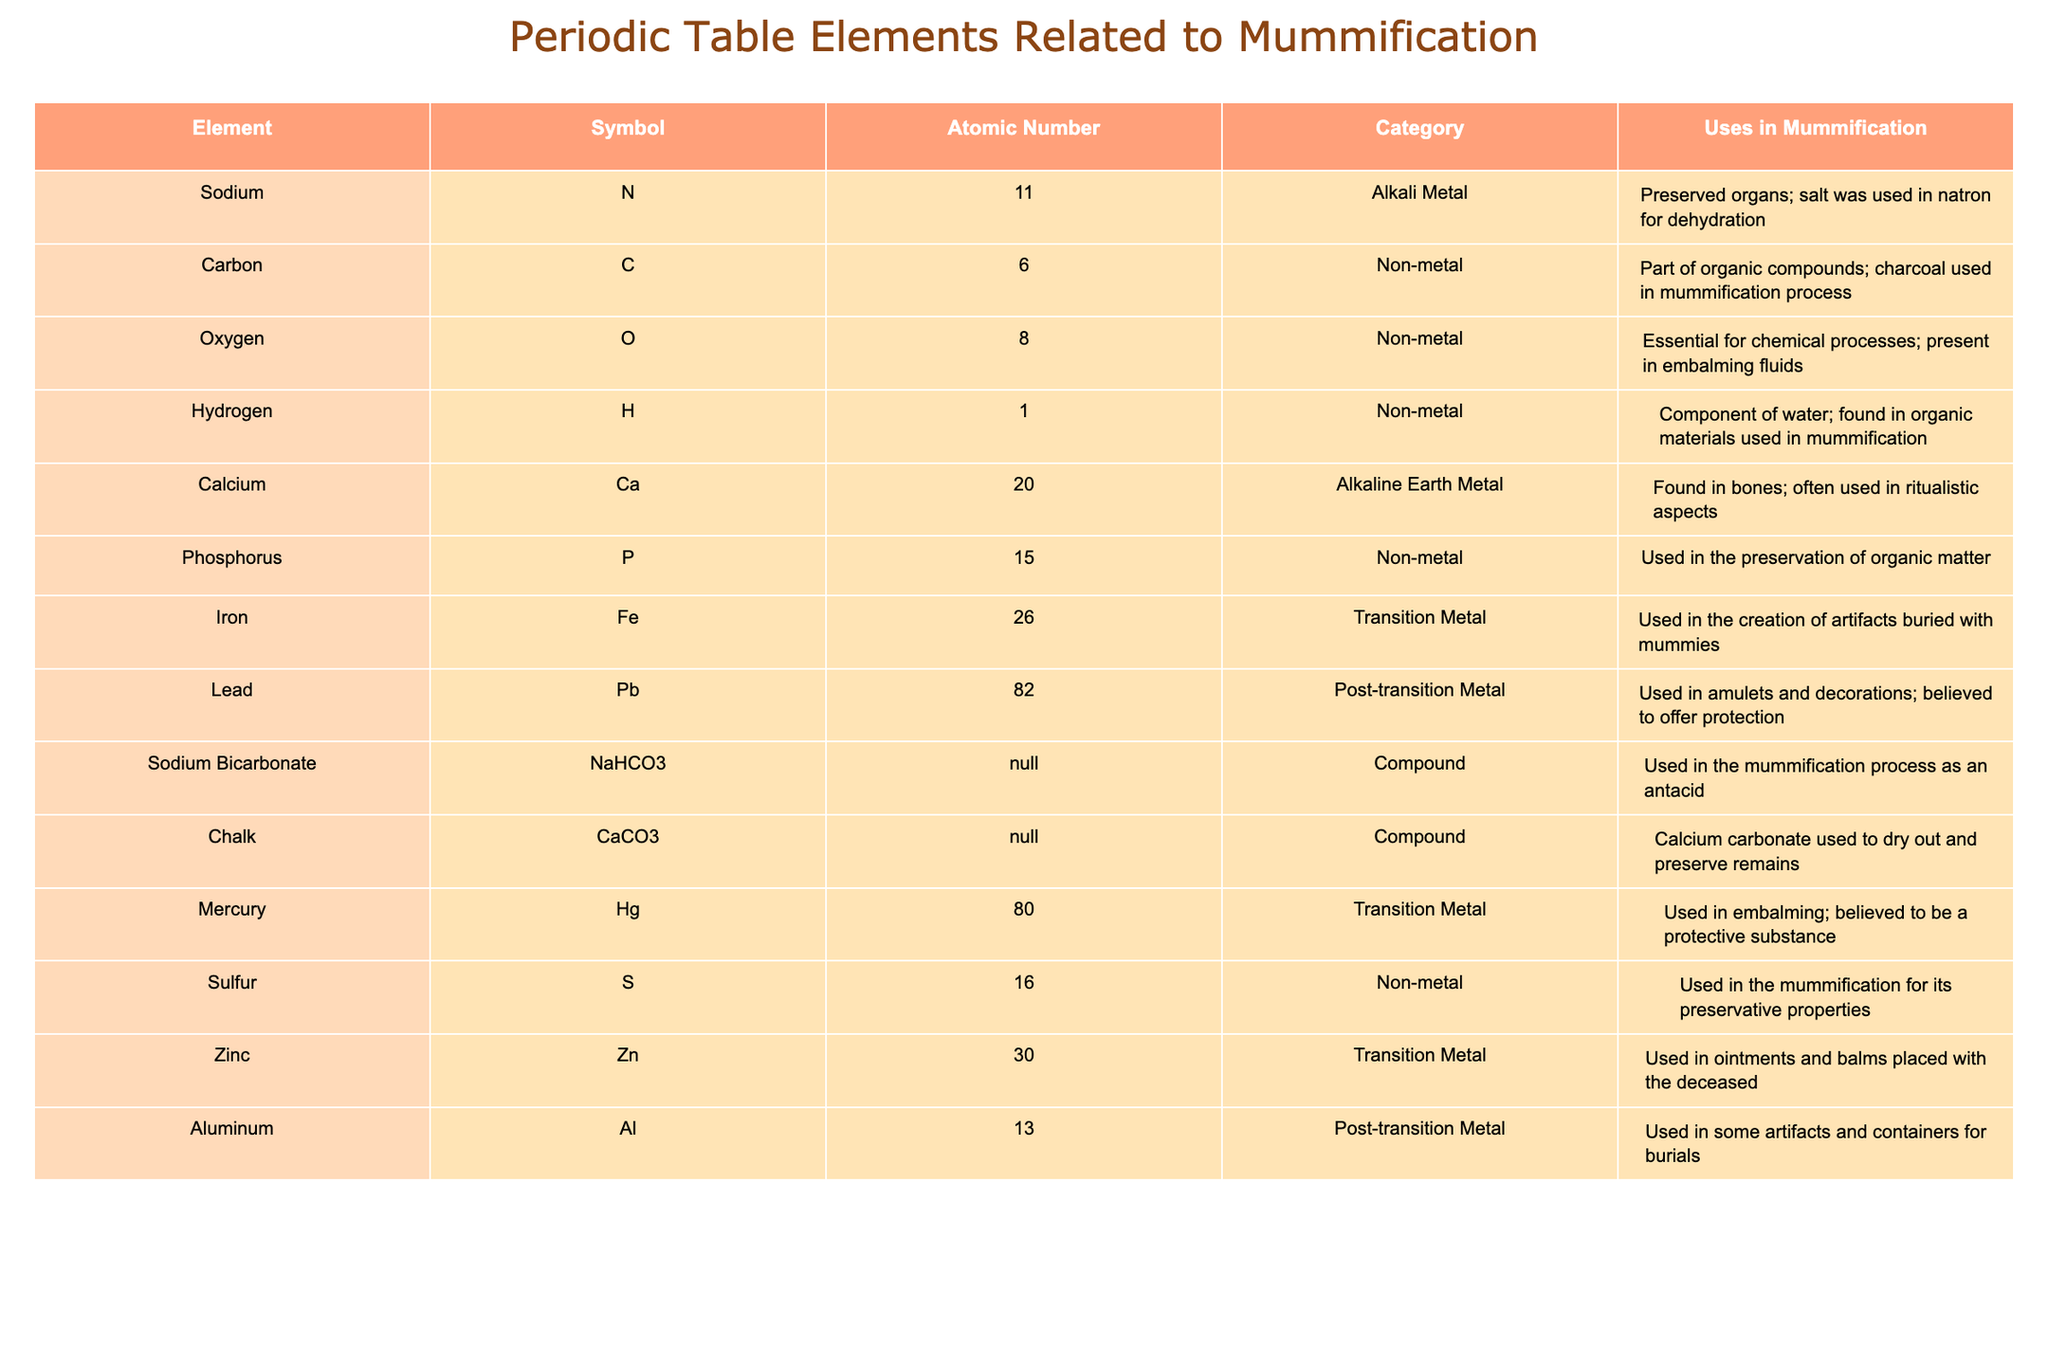What is the symbol for Carbon? The table lists Carbon under the "Element" column, where its symbol is presented in the "Symbol" column directly beside it. The symbol for Carbon is C.
Answer: C Which element has the lowest atomic number among those listed? The atomic numbers for the elements are listed in the "Atomic Number" column. Sodium has the lowest atomic number with 11.
Answer: Sodium How many non-metals are related to mummification? The elements categorized as non-metals can be counted from the "Category" column. The non-metals identified are Carbon, Oxygen, Hydrogen, Phosphorus, Sulfur, totaling 6 elements.
Answer: 6 Is Zinc used in the mummification process? The "Uses in Mummification" column mentions that Zinc is used in ointments and balms placed with the deceased, thus confirming its usage in mummification.
Answer: Yes Which element has the highest atomic number, and what is its use? By scanning the "Atomic Number" column, Lead is identified as having the highest atomic number at 82. Its use, according to the "Uses in Mummification" column, is for amulets and decorations believed to offer protection.
Answer: Lead, protection What is the total number of alkali and alkaline earth metals mentioned in the table? The alkali and alkaline earth metals can be identified from the "Category" column. The metals are Sodium (alkali) and Calcium (alkaline earth), resulting in a total of 2.
Answer: 2 Which element is used in embalming fluids and what role does it play? The table specifies that Oxygen is essential for chemical processes, which includes being part of embalming fluids, making it crucial in mummification.
Answer: Oxygen, essential role Are there more elements categorized as transition metals compared to post-transition metals? By examining the "Category" column, there are 4 transition metals (Iron, Mercury, Zinc) and 2 post-transition metals (Lead, Aluminum). Therefore, there are more transition metals.
Answer: Yes Can you list two elements used in the preservation of organic matter? The "Uses in Mummification" column indicates both Phosphorus and Sulfur are specifically mentioned for their role in the preservation of organic matter.
Answer: Phosphorus, Sulfur 